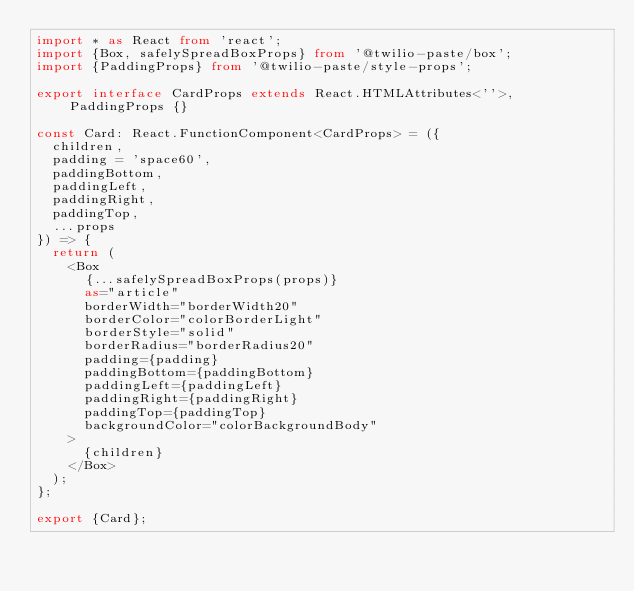Convert code to text. <code><loc_0><loc_0><loc_500><loc_500><_TypeScript_>import * as React from 'react';
import {Box, safelySpreadBoxProps} from '@twilio-paste/box';
import {PaddingProps} from '@twilio-paste/style-props';

export interface CardProps extends React.HTMLAttributes<''>, PaddingProps {}

const Card: React.FunctionComponent<CardProps> = ({
  children,
  padding = 'space60',
  paddingBottom,
  paddingLeft,
  paddingRight,
  paddingTop,
  ...props
}) => {
  return (
    <Box
      {...safelySpreadBoxProps(props)}
      as="article"
      borderWidth="borderWidth20"
      borderColor="colorBorderLight"
      borderStyle="solid"
      borderRadius="borderRadius20"
      padding={padding}
      paddingBottom={paddingBottom}
      paddingLeft={paddingLeft}
      paddingRight={paddingRight}
      paddingTop={paddingTop}
      backgroundColor="colorBackgroundBody"
    >
      {children}
    </Box>
  );
};

export {Card};
</code> 